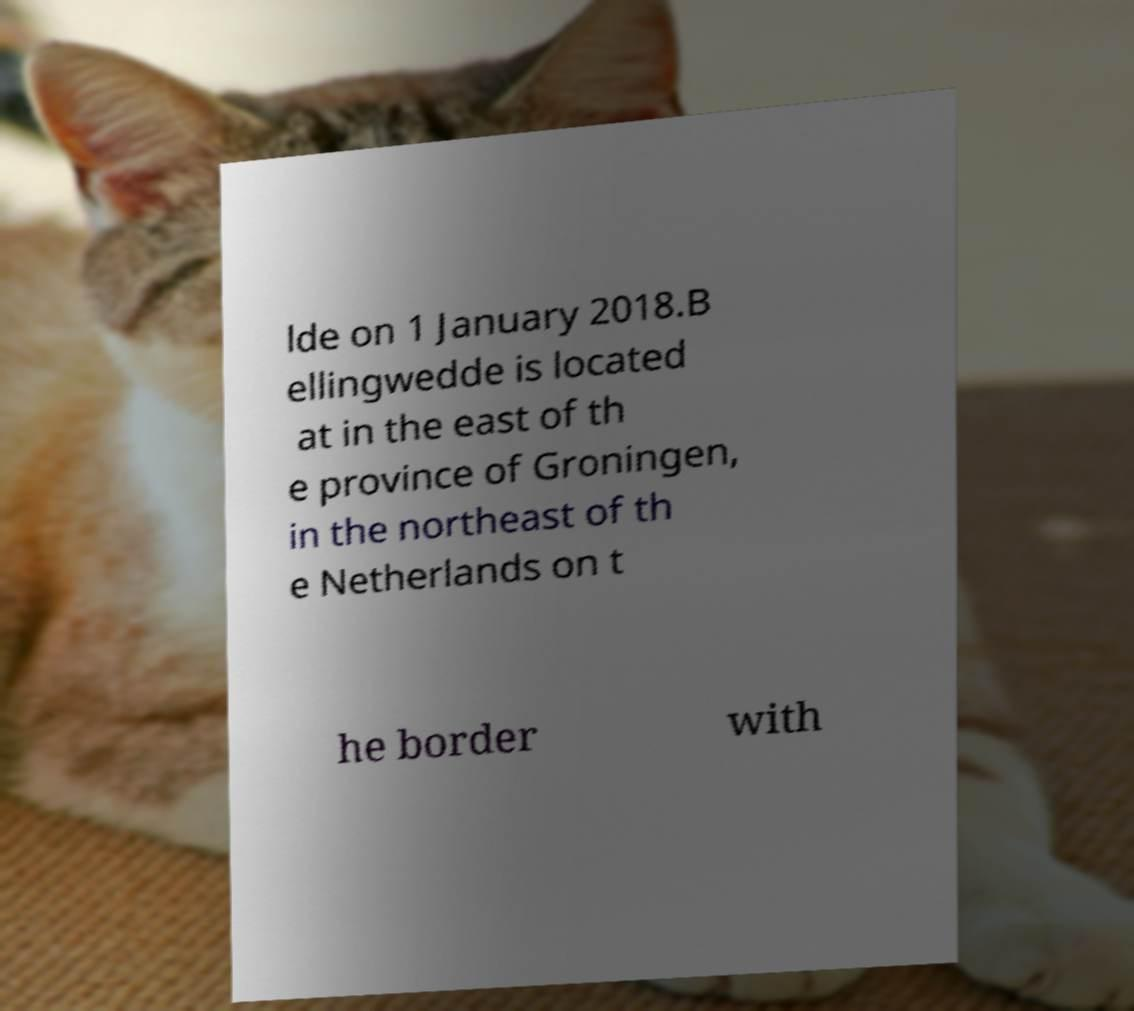Please read and relay the text visible in this image. What does it say? lde on 1 January 2018.B ellingwedde is located at in the east of th e province of Groningen, in the northeast of th e Netherlands on t he border with 